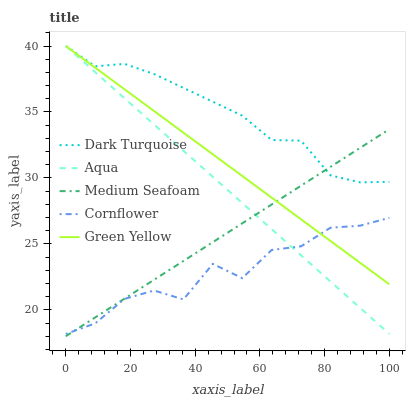Does Green Yellow have the minimum area under the curve?
Answer yes or no. No. Does Green Yellow have the maximum area under the curve?
Answer yes or no. No. Is Green Yellow the smoothest?
Answer yes or no. No. Is Green Yellow the roughest?
Answer yes or no. No. Does Green Yellow have the lowest value?
Answer yes or no. No. Does Medium Seafoam have the highest value?
Answer yes or no. No. Is Cornflower less than Dark Turquoise?
Answer yes or no. Yes. Is Dark Turquoise greater than Cornflower?
Answer yes or no. Yes. Does Cornflower intersect Dark Turquoise?
Answer yes or no. No. 